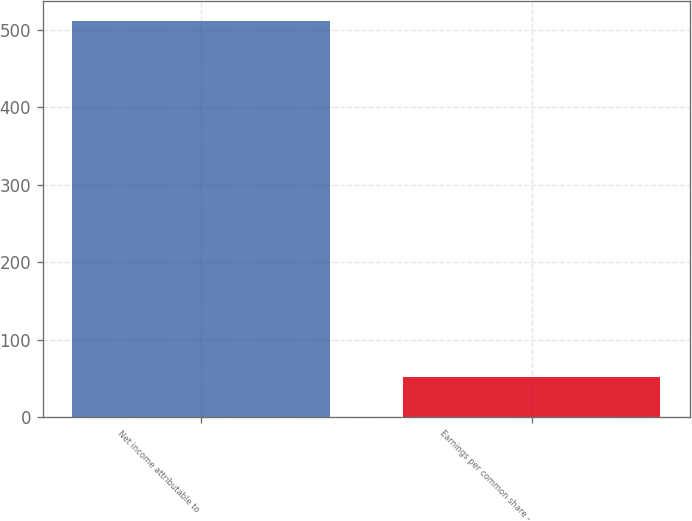Convert chart. <chart><loc_0><loc_0><loc_500><loc_500><bar_chart><fcel>Net income attributable to<fcel>Earnings per common share -<nl><fcel>512<fcel>52.26<nl></chart> 